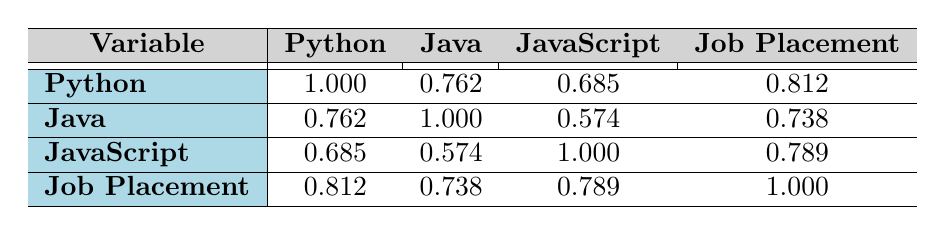What is the correlation between Python proficiency and job placement success? According to the table, the correlation value between Python proficiency and job placement success is 0.812. This indicates a strong positive correlation, suggesting that higher Python proficiency is associated with a higher chance of job placement success.
Answer: 0.812 What is the lowest correlation value among the programming languages in relation to job placement success? The correlations to job placement success for each language are: Python (0.812), Java (0.738), and JavaScript (0.789). The lowest correlation value among these is for Java, which is 0.738.
Answer: 0.738 If a graduate has a Java proficiency score of 90, what can we infer about their job placement success based on the correlations? The correlation between Java proficiency and job placement success is 0.738. While this suggests a positive relationship, it does not guarantee job placement success for a specific score. However, given that 90 is above average, the probability of job placement success is likely increased.
Answer: Likely increased chance of success Is there a strong correlation between JavaScript proficiency and Python proficiency? The correlation value between JavaScript and Python proficiency is 0.685, which indicates a moderate positive correlation. This means that as Python proficiency increases, JavaScript proficiency tends to increase as well, but it is not extremely strong.
Answer: Yes, moderate correlation What is the average correlation value for the programming language proficiencies with job placement success? The correlation values with job placement success are: Python (0.812), Java (0.738), and JavaScript (0.789). To find the average, we sum these values: 0.812 + 0.738 + 0.789 = 2.339. Dividing by 3 gives us an average of 2.339 / 3 = 0.7797.
Answer: 0.7797 